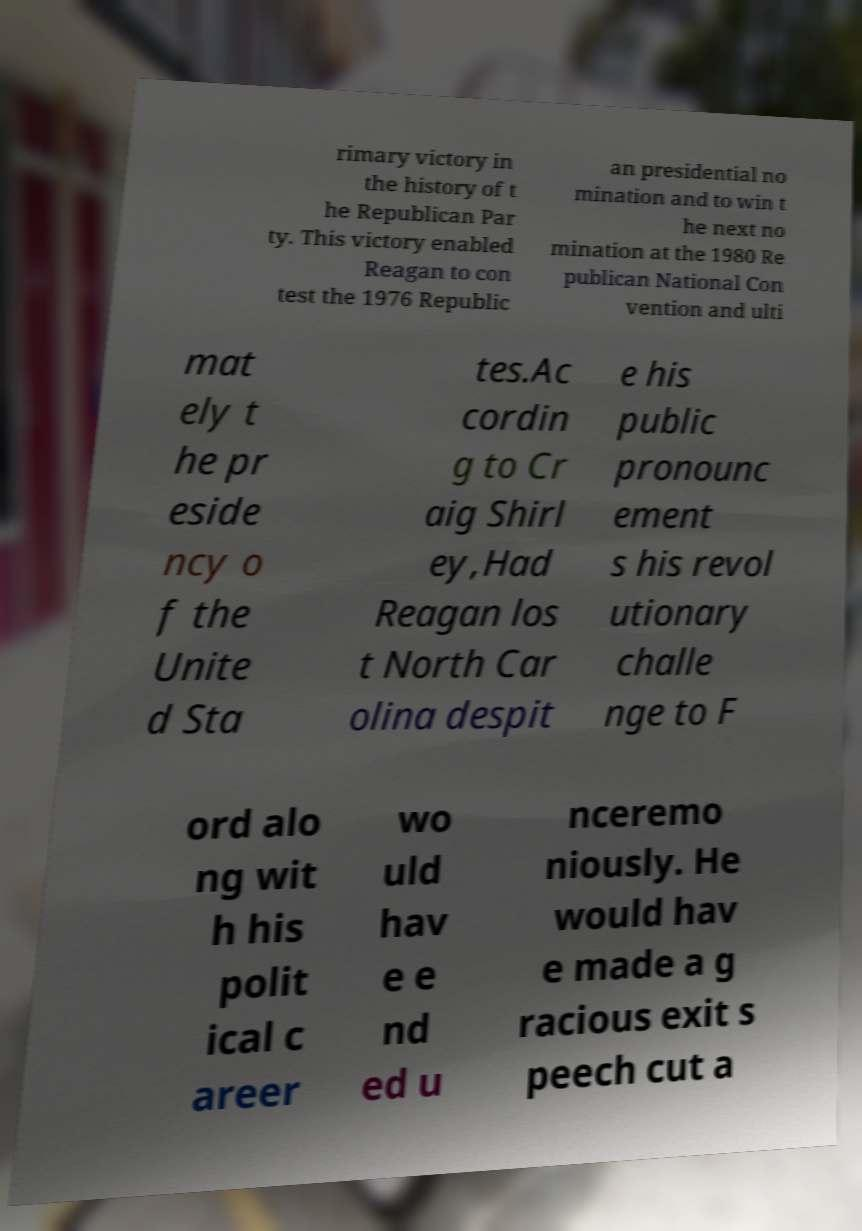For documentation purposes, I need the text within this image transcribed. Could you provide that? rimary victory in the history of t he Republican Par ty. This victory enabled Reagan to con test the 1976 Republic an presidential no mination and to win t he next no mination at the 1980 Re publican National Con vention and ulti mat ely t he pr eside ncy o f the Unite d Sta tes.Ac cordin g to Cr aig Shirl ey,Had Reagan los t North Car olina despit e his public pronounc ement s his revol utionary challe nge to F ord alo ng wit h his polit ical c areer wo uld hav e e nd ed u nceremo niously. He would hav e made a g racious exit s peech cut a 